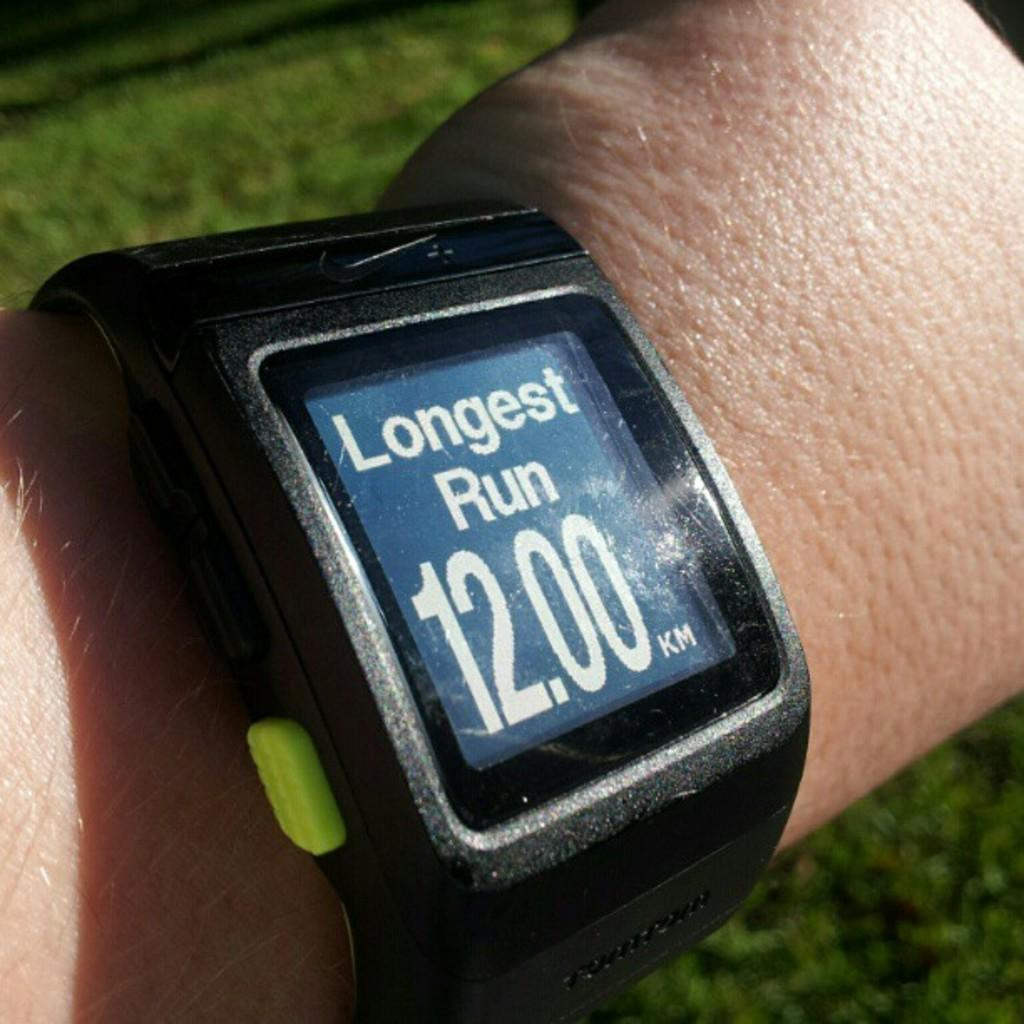<image>
Give a short and clear explanation of the subsequent image. A watch showing the longest run at 12 kilometers 